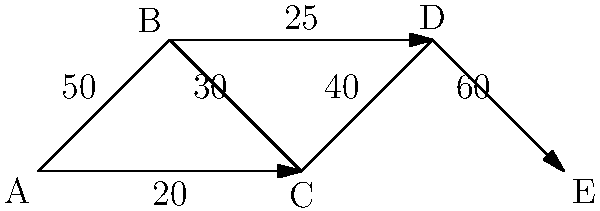In the supply chain network diagram above, each node represents a stage in the process, and the edges represent the flow of goods with their respective capacities. What is the maximum flow that can be achieved from node A to node E, and which edge(s) represent the bottleneck(s) in the system? To find the maximum flow and identify bottlenecks, we'll use the concept of network flow and the max-flow min-cut theorem:

1. Identify all possible paths from A to E:
   Path 1: A → B → C → D → E
   Path 2: A → C → D → E
   Path 3: A → B → D → E

2. Calculate the flow capacity of each path:
   Path 1: min(50, 30, 40, 60) = 30
   Path 2: min(20, 40, 60) = 20
   Path 3: min(50, 25, 60) = 25

3. The maximum flow is the sum of the minimum capacities of all paths:
   Max Flow = 30 + 20 + 25 = 75

4. To identify bottlenecks, look for edges that, if increased, would directly increase the maximum flow:
   - The edge B → C (capacity 30) limits Path 1
   - The edge A → C (capacity 20) limits Path 2
   - The edge B → D (capacity 25) limits Path 3

These three edges are the bottlenecks because they restrict the flow in their respective paths and ultimately determine the maximum flow of the entire network.
Answer: Maximum flow: 75; Bottlenecks: B→C, A→C, B→D 